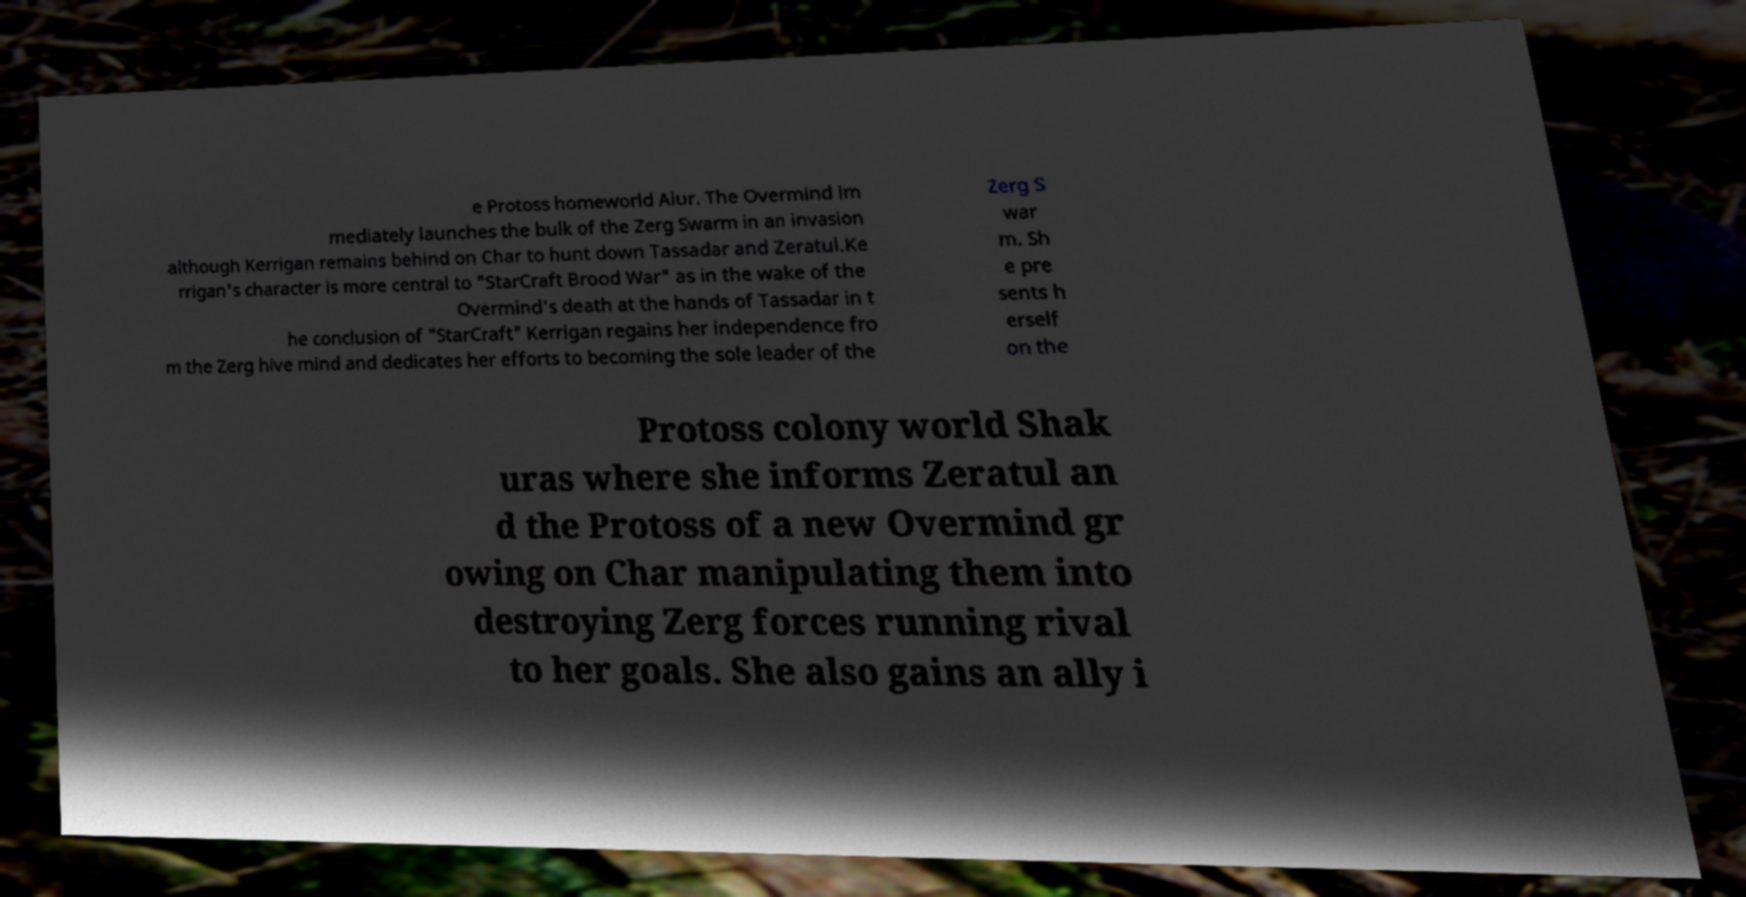What messages or text are displayed in this image? I need them in a readable, typed format. e Protoss homeworld Aiur. The Overmind im mediately launches the bulk of the Zerg Swarm in an invasion although Kerrigan remains behind on Char to hunt down Tassadar and Zeratul.Ke rrigan's character is more central to "StarCraft Brood War" as in the wake of the Overmind's death at the hands of Tassadar in t he conclusion of "StarCraft" Kerrigan regains her independence fro m the Zerg hive mind and dedicates her efforts to becoming the sole leader of the Zerg S war m. Sh e pre sents h erself on the Protoss colony world Shak uras where she informs Zeratul an d the Protoss of a new Overmind gr owing on Char manipulating them into destroying Zerg forces running rival to her goals. She also gains an ally i 